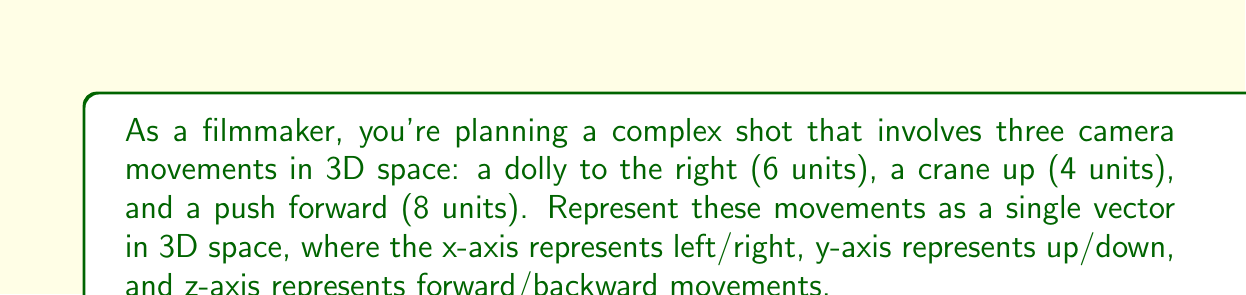Teach me how to tackle this problem. Let's approach this step-by-step:

1) First, we need to understand how each movement corresponds to our 3D coordinate system:
   - Dolly right: This is a movement along the positive x-axis
   - Crane up: This is a movement along the positive y-axis
   - Push forward: This is a movement along the positive z-axis

2) Now, let's assign the magnitudes to each movement:
   - x-axis (right): 6 units
   - y-axis (up): 4 units
   - z-axis (forward): 8 units

3) In vector notation, we can represent this as:

   $$\vec{v} = \begin{pmatrix} 6 \\ 4 \\ 8 \end{pmatrix}$$

4) This vector $\vec{v}$ represents the net movement of the camera in 3D space after all three movements are combined.

5) We can also write this in component form as:

   $$\vec{v} = 6\hat{i} + 4\hat{j} + 8\hat{k}$$

   Where $\hat{i}$, $\hat{j}$, and $\hat{k}$ are unit vectors in the x, y, and z directions respectively.
Answer: $\vec{v} = \begin{pmatrix} 6 \\ 4 \\ 8 \end{pmatrix}$ or $6\hat{i} + 4\hat{j} + 8\hat{k}$ 